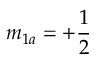Convert formula to latex. <formula><loc_0><loc_0><loc_500><loc_500>m _ { 1 a } = + \frac { 1 } { 2 }</formula> 